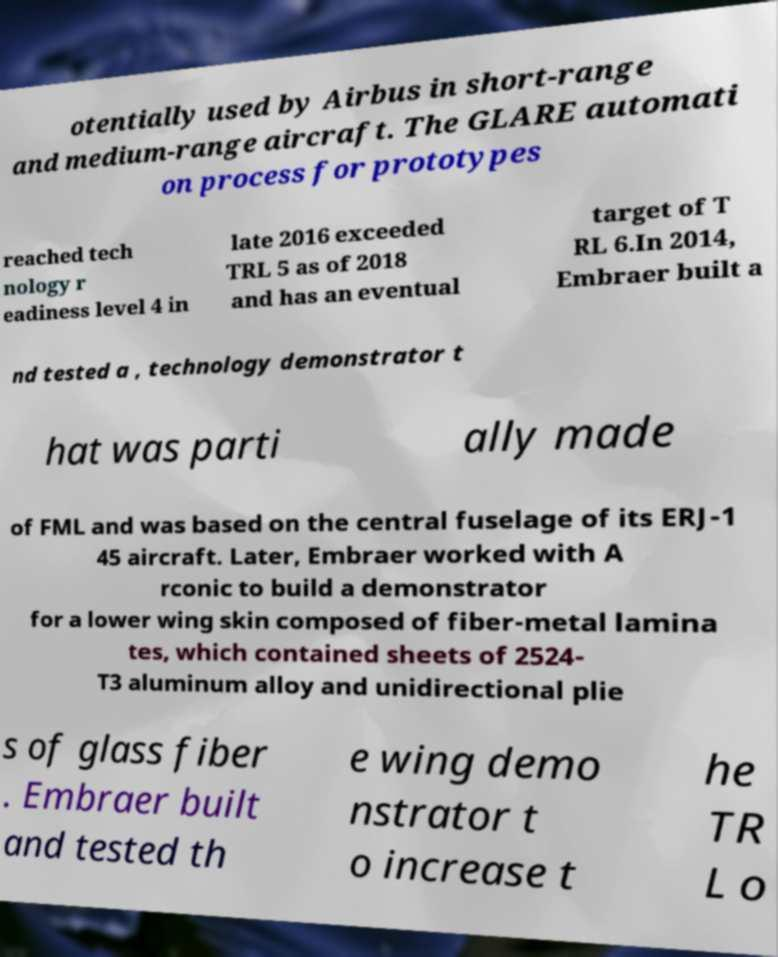Please read and relay the text visible in this image. What does it say? otentially used by Airbus in short-range and medium-range aircraft. The GLARE automati on process for prototypes reached tech nology r eadiness level 4 in late 2016 exceeded TRL 5 as of 2018 and has an eventual target of T RL 6.In 2014, Embraer built a nd tested a , technology demonstrator t hat was parti ally made of FML and was based on the central fuselage of its ERJ-1 45 aircraft. Later, Embraer worked with A rconic to build a demonstrator for a lower wing skin composed of fiber-metal lamina tes, which contained sheets of 2524- T3 aluminum alloy and unidirectional plie s of glass fiber . Embraer built and tested th e wing demo nstrator t o increase t he TR L o 